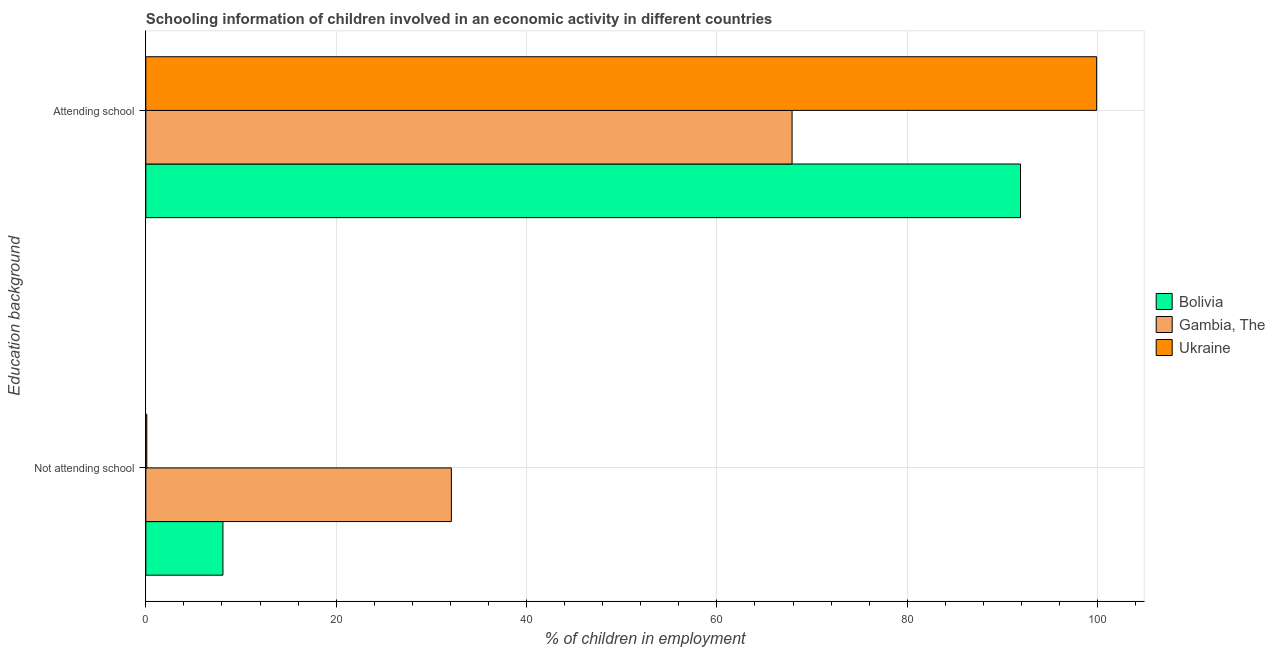How many different coloured bars are there?
Ensure brevity in your answer.  3. Are the number of bars per tick equal to the number of legend labels?
Offer a very short reply. Yes. How many bars are there on the 1st tick from the top?
Make the answer very short. 3. What is the label of the 1st group of bars from the top?
Give a very brief answer. Attending school. What is the percentage of employed children who are not attending school in Gambia, The?
Keep it short and to the point. 32.1. Across all countries, what is the maximum percentage of employed children who are not attending school?
Your response must be concise. 32.1. Across all countries, what is the minimum percentage of employed children who are attending school?
Keep it short and to the point. 67.9. In which country was the percentage of employed children who are attending school maximum?
Ensure brevity in your answer.  Ukraine. In which country was the percentage of employed children who are not attending school minimum?
Offer a terse response. Ukraine. What is the total percentage of employed children who are attending school in the graph?
Offer a very short reply. 259.7. What is the difference between the percentage of employed children who are not attending school in Bolivia and the percentage of employed children who are attending school in Gambia, The?
Provide a succinct answer. -59.8. What is the average percentage of employed children who are attending school per country?
Keep it short and to the point. 86.57. What is the difference between the percentage of employed children who are attending school and percentage of employed children who are not attending school in Ukraine?
Ensure brevity in your answer.  99.8. In how many countries, is the percentage of employed children who are not attending school greater than 44 %?
Your answer should be compact. 0. What is the ratio of the percentage of employed children who are attending school in Bolivia to that in Ukraine?
Give a very brief answer. 0.92. What does the 1st bar from the top in Not attending school represents?
Provide a succinct answer. Ukraine. What does the 2nd bar from the bottom in Attending school represents?
Keep it short and to the point. Gambia, The. Are all the bars in the graph horizontal?
Offer a terse response. Yes. How many countries are there in the graph?
Your answer should be very brief. 3. Are the values on the major ticks of X-axis written in scientific E-notation?
Keep it short and to the point. No. Does the graph contain any zero values?
Give a very brief answer. No. Does the graph contain grids?
Ensure brevity in your answer.  Yes. What is the title of the graph?
Offer a terse response. Schooling information of children involved in an economic activity in different countries. Does "Uganda" appear as one of the legend labels in the graph?
Offer a very short reply. No. What is the label or title of the X-axis?
Your answer should be compact. % of children in employment. What is the label or title of the Y-axis?
Keep it short and to the point. Education background. What is the % of children in employment in Bolivia in Not attending school?
Your answer should be very brief. 8.1. What is the % of children in employment of Gambia, The in Not attending school?
Your response must be concise. 32.1. What is the % of children in employment of Bolivia in Attending school?
Provide a short and direct response. 91.9. What is the % of children in employment of Gambia, The in Attending school?
Offer a terse response. 67.9. What is the % of children in employment in Ukraine in Attending school?
Offer a terse response. 99.9. Across all Education background, what is the maximum % of children in employment of Bolivia?
Make the answer very short. 91.9. Across all Education background, what is the maximum % of children in employment of Gambia, The?
Make the answer very short. 67.9. Across all Education background, what is the maximum % of children in employment of Ukraine?
Provide a succinct answer. 99.9. Across all Education background, what is the minimum % of children in employment of Bolivia?
Offer a terse response. 8.1. Across all Education background, what is the minimum % of children in employment of Gambia, The?
Provide a short and direct response. 32.1. Across all Education background, what is the minimum % of children in employment of Ukraine?
Make the answer very short. 0.1. What is the total % of children in employment in Bolivia in the graph?
Offer a terse response. 100. What is the total % of children in employment of Gambia, The in the graph?
Make the answer very short. 100. What is the difference between the % of children in employment of Bolivia in Not attending school and that in Attending school?
Make the answer very short. -83.8. What is the difference between the % of children in employment in Gambia, The in Not attending school and that in Attending school?
Provide a short and direct response. -35.8. What is the difference between the % of children in employment of Ukraine in Not attending school and that in Attending school?
Provide a succinct answer. -99.8. What is the difference between the % of children in employment of Bolivia in Not attending school and the % of children in employment of Gambia, The in Attending school?
Keep it short and to the point. -59.8. What is the difference between the % of children in employment in Bolivia in Not attending school and the % of children in employment in Ukraine in Attending school?
Your answer should be very brief. -91.8. What is the difference between the % of children in employment in Gambia, The in Not attending school and the % of children in employment in Ukraine in Attending school?
Keep it short and to the point. -67.8. What is the average % of children in employment of Gambia, The per Education background?
Offer a terse response. 50. What is the average % of children in employment of Ukraine per Education background?
Give a very brief answer. 50. What is the difference between the % of children in employment of Bolivia and % of children in employment of Ukraine in Attending school?
Your answer should be compact. -8. What is the difference between the % of children in employment of Gambia, The and % of children in employment of Ukraine in Attending school?
Ensure brevity in your answer.  -32. What is the ratio of the % of children in employment in Bolivia in Not attending school to that in Attending school?
Ensure brevity in your answer.  0.09. What is the ratio of the % of children in employment in Gambia, The in Not attending school to that in Attending school?
Ensure brevity in your answer.  0.47. What is the ratio of the % of children in employment in Ukraine in Not attending school to that in Attending school?
Ensure brevity in your answer.  0. What is the difference between the highest and the second highest % of children in employment of Bolivia?
Provide a succinct answer. 83.8. What is the difference between the highest and the second highest % of children in employment of Gambia, The?
Give a very brief answer. 35.8. What is the difference between the highest and the second highest % of children in employment of Ukraine?
Keep it short and to the point. 99.8. What is the difference between the highest and the lowest % of children in employment in Bolivia?
Provide a short and direct response. 83.8. What is the difference between the highest and the lowest % of children in employment of Gambia, The?
Make the answer very short. 35.8. What is the difference between the highest and the lowest % of children in employment in Ukraine?
Your answer should be compact. 99.8. 